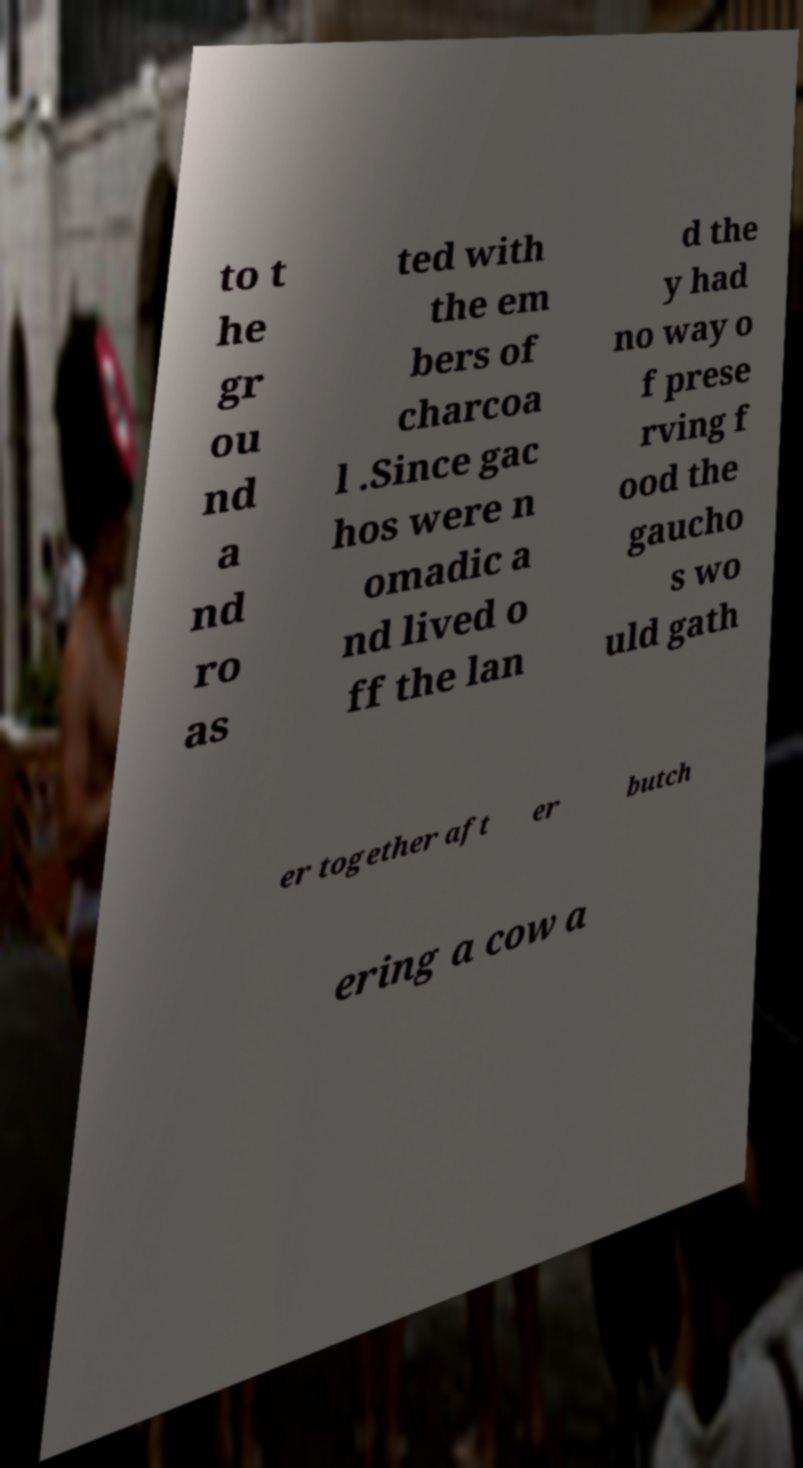Could you extract and type out the text from this image? to t he gr ou nd a nd ro as ted with the em bers of charcoa l .Since gac hos were n omadic a nd lived o ff the lan d the y had no way o f prese rving f ood the gaucho s wo uld gath er together aft er butch ering a cow a 